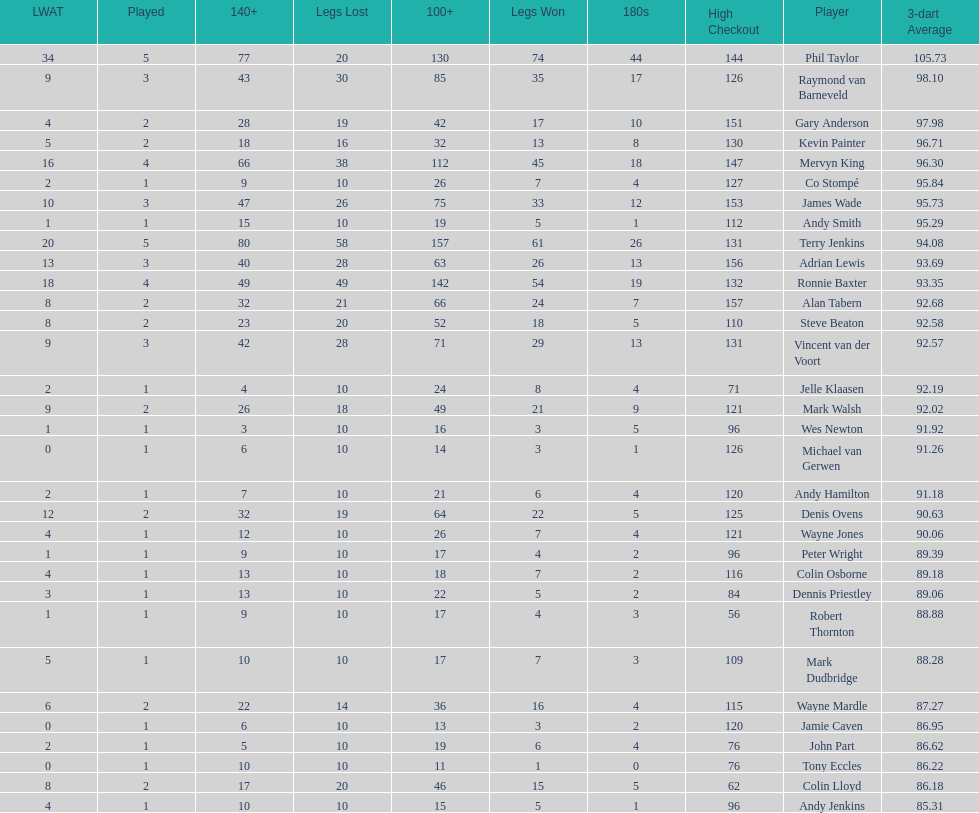How many players in the 2009 world matchplay won at least 30 legs? 6. 